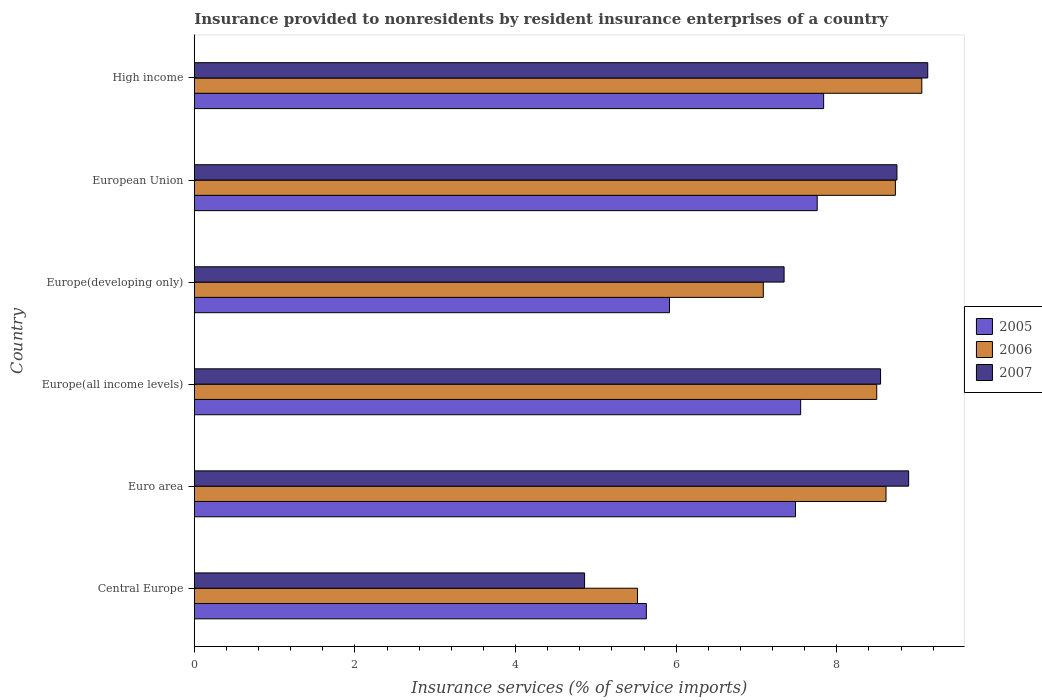Are the number of bars per tick equal to the number of legend labels?
Offer a very short reply. Yes. Are the number of bars on each tick of the Y-axis equal?
Keep it short and to the point. Yes. How many bars are there on the 4th tick from the top?
Offer a terse response. 3. How many bars are there on the 3rd tick from the bottom?
Offer a terse response. 3. What is the label of the 1st group of bars from the top?
Make the answer very short. High income. What is the insurance provided to nonresidents in 2005 in Europe(all income levels)?
Keep it short and to the point. 7.55. Across all countries, what is the maximum insurance provided to nonresidents in 2006?
Your answer should be very brief. 9.06. Across all countries, what is the minimum insurance provided to nonresidents in 2007?
Provide a short and direct response. 4.86. In which country was the insurance provided to nonresidents in 2005 minimum?
Your response must be concise. Central Europe. What is the total insurance provided to nonresidents in 2006 in the graph?
Your response must be concise. 47.5. What is the difference between the insurance provided to nonresidents in 2007 in Europe(all income levels) and that in European Union?
Give a very brief answer. -0.2. What is the difference between the insurance provided to nonresidents in 2007 in Euro area and the insurance provided to nonresidents in 2005 in Europe(all income levels)?
Ensure brevity in your answer.  1.34. What is the average insurance provided to nonresidents in 2007 per country?
Provide a succinct answer. 7.92. What is the difference between the insurance provided to nonresidents in 2006 and insurance provided to nonresidents in 2007 in High income?
Offer a terse response. -0.07. What is the ratio of the insurance provided to nonresidents in 2006 in European Union to that in High income?
Offer a terse response. 0.96. Is the insurance provided to nonresidents in 2005 in European Union less than that in High income?
Your answer should be very brief. Yes. What is the difference between the highest and the second highest insurance provided to nonresidents in 2005?
Offer a terse response. 0.08. What is the difference between the highest and the lowest insurance provided to nonresidents in 2006?
Keep it short and to the point. 3.54. What does the 2nd bar from the bottom in Europe(all income levels) represents?
Your answer should be compact. 2006. How many countries are there in the graph?
Your answer should be compact. 6. What is the difference between two consecutive major ticks on the X-axis?
Provide a succinct answer. 2. Are the values on the major ticks of X-axis written in scientific E-notation?
Offer a very short reply. No. Does the graph contain grids?
Keep it short and to the point. No. Where does the legend appear in the graph?
Offer a terse response. Center right. How are the legend labels stacked?
Give a very brief answer. Vertical. What is the title of the graph?
Keep it short and to the point. Insurance provided to nonresidents by resident insurance enterprises of a country. What is the label or title of the X-axis?
Give a very brief answer. Insurance services (% of service imports). What is the Insurance services (% of service imports) in 2005 in Central Europe?
Ensure brevity in your answer.  5.63. What is the Insurance services (% of service imports) of 2006 in Central Europe?
Make the answer very short. 5.52. What is the Insurance services (% of service imports) in 2007 in Central Europe?
Offer a very short reply. 4.86. What is the Insurance services (% of service imports) of 2005 in Euro area?
Provide a succinct answer. 7.49. What is the Insurance services (% of service imports) in 2006 in Euro area?
Give a very brief answer. 8.61. What is the Insurance services (% of service imports) in 2007 in Euro area?
Your answer should be compact. 8.9. What is the Insurance services (% of service imports) of 2005 in Europe(all income levels)?
Your response must be concise. 7.55. What is the Insurance services (% of service imports) in 2006 in Europe(all income levels)?
Provide a succinct answer. 8.5. What is the Insurance services (% of service imports) in 2007 in Europe(all income levels)?
Provide a succinct answer. 8.55. What is the Insurance services (% of service imports) of 2005 in Europe(developing only)?
Provide a succinct answer. 5.92. What is the Insurance services (% of service imports) in 2006 in Europe(developing only)?
Your answer should be compact. 7.09. What is the Insurance services (% of service imports) of 2007 in Europe(developing only)?
Keep it short and to the point. 7.34. What is the Insurance services (% of service imports) in 2005 in European Union?
Make the answer very short. 7.76. What is the Insurance services (% of service imports) in 2006 in European Union?
Your answer should be compact. 8.73. What is the Insurance services (% of service imports) of 2007 in European Union?
Make the answer very short. 8.75. What is the Insurance services (% of service imports) in 2005 in High income?
Ensure brevity in your answer.  7.84. What is the Insurance services (% of service imports) of 2006 in High income?
Keep it short and to the point. 9.06. What is the Insurance services (% of service imports) of 2007 in High income?
Provide a short and direct response. 9.13. Across all countries, what is the maximum Insurance services (% of service imports) in 2005?
Your response must be concise. 7.84. Across all countries, what is the maximum Insurance services (% of service imports) of 2006?
Provide a short and direct response. 9.06. Across all countries, what is the maximum Insurance services (% of service imports) in 2007?
Keep it short and to the point. 9.13. Across all countries, what is the minimum Insurance services (% of service imports) in 2005?
Your response must be concise. 5.63. Across all countries, what is the minimum Insurance services (% of service imports) in 2006?
Ensure brevity in your answer.  5.52. Across all countries, what is the minimum Insurance services (% of service imports) of 2007?
Make the answer very short. 4.86. What is the total Insurance services (% of service imports) in 2005 in the graph?
Ensure brevity in your answer.  42.18. What is the total Insurance services (% of service imports) in 2006 in the graph?
Provide a succinct answer. 47.5. What is the total Insurance services (% of service imports) in 2007 in the graph?
Make the answer very short. 47.53. What is the difference between the Insurance services (% of service imports) of 2005 in Central Europe and that in Euro area?
Provide a succinct answer. -1.86. What is the difference between the Insurance services (% of service imports) of 2006 in Central Europe and that in Euro area?
Your answer should be compact. -3.09. What is the difference between the Insurance services (% of service imports) in 2007 in Central Europe and that in Euro area?
Ensure brevity in your answer.  -4.04. What is the difference between the Insurance services (% of service imports) in 2005 in Central Europe and that in Europe(all income levels)?
Give a very brief answer. -1.92. What is the difference between the Insurance services (% of service imports) of 2006 in Central Europe and that in Europe(all income levels)?
Your answer should be compact. -2.98. What is the difference between the Insurance services (% of service imports) in 2007 in Central Europe and that in Europe(all income levels)?
Ensure brevity in your answer.  -3.69. What is the difference between the Insurance services (% of service imports) of 2005 in Central Europe and that in Europe(developing only)?
Offer a terse response. -0.29. What is the difference between the Insurance services (% of service imports) of 2006 in Central Europe and that in Europe(developing only)?
Make the answer very short. -1.57. What is the difference between the Insurance services (% of service imports) of 2007 in Central Europe and that in Europe(developing only)?
Ensure brevity in your answer.  -2.48. What is the difference between the Insurance services (% of service imports) in 2005 in Central Europe and that in European Union?
Offer a terse response. -2.13. What is the difference between the Insurance services (% of service imports) of 2006 in Central Europe and that in European Union?
Provide a succinct answer. -3.21. What is the difference between the Insurance services (% of service imports) in 2007 in Central Europe and that in European Union?
Make the answer very short. -3.89. What is the difference between the Insurance services (% of service imports) of 2005 in Central Europe and that in High income?
Provide a succinct answer. -2.21. What is the difference between the Insurance services (% of service imports) of 2006 in Central Europe and that in High income?
Your response must be concise. -3.54. What is the difference between the Insurance services (% of service imports) in 2007 in Central Europe and that in High income?
Provide a short and direct response. -4.27. What is the difference between the Insurance services (% of service imports) of 2005 in Euro area and that in Europe(all income levels)?
Make the answer very short. -0.06. What is the difference between the Insurance services (% of service imports) in 2006 in Euro area and that in Europe(all income levels)?
Your answer should be very brief. 0.12. What is the difference between the Insurance services (% of service imports) of 2007 in Euro area and that in Europe(all income levels)?
Ensure brevity in your answer.  0.35. What is the difference between the Insurance services (% of service imports) of 2005 in Euro area and that in Europe(developing only)?
Offer a terse response. 1.57. What is the difference between the Insurance services (% of service imports) of 2006 in Euro area and that in Europe(developing only)?
Your response must be concise. 1.53. What is the difference between the Insurance services (% of service imports) in 2007 in Euro area and that in Europe(developing only)?
Make the answer very short. 1.55. What is the difference between the Insurance services (% of service imports) in 2005 in Euro area and that in European Union?
Your response must be concise. -0.27. What is the difference between the Insurance services (% of service imports) in 2006 in Euro area and that in European Union?
Provide a short and direct response. -0.12. What is the difference between the Insurance services (% of service imports) of 2007 in Euro area and that in European Union?
Provide a succinct answer. 0.15. What is the difference between the Insurance services (% of service imports) of 2005 in Euro area and that in High income?
Your response must be concise. -0.35. What is the difference between the Insurance services (% of service imports) in 2006 in Euro area and that in High income?
Your response must be concise. -0.45. What is the difference between the Insurance services (% of service imports) of 2007 in Euro area and that in High income?
Your response must be concise. -0.24. What is the difference between the Insurance services (% of service imports) of 2005 in Europe(all income levels) and that in Europe(developing only)?
Your answer should be very brief. 1.63. What is the difference between the Insurance services (% of service imports) in 2006 in Europe(all income levels) and that in Europe(developing only)?
Your answer should be compact. 1.41. What is the difference between the Insurance services (% of service imports) in 2007 in Europe(all income levels) and that in Europe(developing only)?
Offer a terse response. 1.2. What is the difference between the Insurance services (% of service imports) of 2005 in Europe(all income levels) and that in European Union?
Your response must be concise. -0.21. What is the difference between the Insurance services (% of service imports) of 2006 in Europe(all income levels) and that in European Union?
Your answer should be very brief. -0.23. What is the difference between the Insurance services (% of service imports) in 2007 in Europe(all income levels) and that in European Union?
Offer a very short reply. -0.2. What is the difference between the Insurance services (% of service imports) of 2005 in Europe(all income levels) and that in High income?
Your answer should be compact. -0.29. What is the difference between the Insurance services (% of service imports) of 2006 in Europe(all income levels) and that in High income?
Offer a terse response. -0.56. What is the difference between the Insurance services (% of service imports) of 2007 in Europe(all income levels) and that in High income?
Your answer should be compact. -0.59. What is the difference between the Insurance services (% of service imports) in 2005 in Europe(developing only) and that in European Union?
Offer a very short reply. -1.84. What is the difference between the Insurance services (% of service imports) of 2006 in Europe(developing only) and that in European Union?
Offer a terse response. -1.64. What is the difference between the Insurance services (% of service imports) in 2007 in Europe(developing only) and that in European Union?
Your answer should be very brief. -1.41. What is the difference between the Insurance services (% of service imports) of 2005 in Europe(developing only) and that in High income?
Provide a succinct answer. -1.92. What is the difference between the Insurance services (% of service imports) of 2006 in Europe(developing only) and that in High income?
Your answer should be compact. -1.97. What is the difference between the Insurance services (% of service imports) of 2007 in Europe(developing only) and that in High income?
Your response must be concise. -1.79. What is the difference between the Insurance services (% of service imports) in 2005 in European Union and that in High income?
Keep it short and to the point. -0.08. What is the difference between the Insurance services (% of service imports) in 2006 in European Union and that in High income?
Your answer should be very brief. -0.33. What is the difference between the Insurance services (% of service imports) of 2007 in European Union and that in High income?
Provide a short and direct response. -0.38. What is the difference between the Insurance services (% of service imports) in 2005 in Central Europe and the Insurance services (% of service imports) in 2006 in Euro area?
Provide a short and direct response. -2.98. What is the difference between the Insurance services (% of service imports) of 2005 in Central Europe and the Insurance services (% of service imports) of 2007 in Euro area?
Provide a succinct answer. -3.27. What is the difference between the Insurance services (% of service imports) of 2006 in Central Europe and the Insurance services (% of service imports) of 2007 in Euro area?
Ensure brevity in your answer.  -3.38. What is the difference between the Insurance services (% of service imports) in 2005 in Central Europe and the Insurance services (% of service imports) in 2006 in Europe(all income levels)?
Provide a succinct answer. -2.87. What is the difference between the Insurance services (% of service imports) of 2005 in Central Europe and the Insurance services (% of service imports) of 2007 in Europe(all income levels)?
Provide a succinct answer. -2.92. What is the difference between the Insurance services (% of service imports) in 2006 in Central Europe and the Insurance services (% of service imports) in 2007 in Europe(all income levels)?
Offer a terse response. -3.03. What is the difference between the Insurance services (% of service imports) of 2005 in Central Europe and the Insurance services (% of service imports) of 2006 in Europe(developing only)?
Offer a terse response. -1.46. What is the difference between the Insurance services (% of service imports) in 2005 in Central Europe and the Insurance services (% of service imports) in 2007 in Europe(developing only)?
Give a very brief answer. -1.72. What is the difference between the Insurance services (% of service imports) in 2006 in Central Europe and the Insurance services (% of service imports) in 2007 in Europe(developing only)?
Provide a short and direct response. -1.83. What is the difference between the Insurance services (% of service imports) in 2005 in Central Europe and the Insurance services (% of service imports) in 2006 in European Union?
Your response must be concise. -3.1. What is the difference between the Insurance services (% of service imports) of 2005 in Central Europe and the Insurance services (% of service imports) of 2007 in European Union?
Ensure brevity in your answer.  -3.12. What is the difference between the Insurance services (% of service imports) in 2006 in Central Europe and the Insurance services (% of service imports) in 2007 in European Union?
Provide a succinct answer. -3.23. What is the difference between the Insurance services (% of service imports) in 2005 in Central Europe and the Insurance services (% of service imports) in 2006 in High income?
Your answer should be very brief. -3.43. What is the difference between the Insurance services (% of service imports) in 2005 in Central Europe and the Insurance services (% of service imports) in 2007 in High income?
Make the answer very short. -3.5. What is the difference between the Insurance services (% of service imports) in 2006 in Central Europe and the Insurance services (% of service imports) in 2007 in High income?
Your answer should be very brief. -3.61. What is the difference between the Insurance services (% of service imports) in 2005 in Euro area and the Insurance services (% of service imports) in 2006 in Europe(all income levels)?
Offer a very short reply. -1.01. What is the difference between the Insurance services (% of service imports) of 2005 in Euro area and the Insurance services (% of service imports) of 2007 in Europe(all income levels)?
Your answer should be very brief. -1.06. What is the difference between the Insurance services (% of service imports) in 2006 in Euro area and the Insurance services (% of service imports) in 2007 in Europe(all income levels)?
Your answer should be compact. 0.07. What is the difference between the Insurance services (% of service imports) in 2005 in Euro area and the Insurance services (% of service imports) in 2006 in Europe(developing only)?
Offer a terse response. 0.4. What is the difference between the Insurance services (% of service imports) in 2005 in Euro area and the Insurance services (% of service imports) in 2007 in Europe(developing only)?
Your answer should be compact. 0.14. What is the difference between the Insurance services (% of service imports) of 2006 in Euro area and the Insurance services (% of service imports) of 2007 in Europe(developing only)?
Make the answer very short. 1.27. What is the difference between the Insurance services (% of service imports) in 2005 in Euro area and the Insurance services (% of service imports) in 2006 in European Union?
Give a very brief answer. -1.24. What is the difference between the Insurance services (% of service imports) of 2005 in Euro area and the Insurance services (% of service imports) of 2007 in European Union?
Ensure brevity in your answer.  -1.26. What is the difference between the Insurance services (% of service imports) in 2006 in Euro area and the Insurance services (% of service imports) in 2007 in European Union?
Offer a very short reply. -0.14. What is the difference between the Insurance services (% of service imports) of 2005 in Euro area and the Insurance services (% of service imports) of 2006 in High income?
Make the answer very short. -1.57. What is the difference between the Insurance services (% of service imports) of 2005 in Euro area and the Insurance services (% of service imports) of 2007 in High income?
Keep it short and to the point. -1.65. What is the difference between the Insurance services (% of service imports) of 2006 in Euro area and the Insurance services (% of service imports) of 2007 in High income?
Your answer should be compact. -0.52. What is the difference between the Insurance services (% of service imports) of 2005 in Europe(all income levels) and the Insurance services (% of service imports) of 2006 in Europe(developing only)?
Give a very brief answer. 0.47. What is the difference between the Insurance services (% of service imports) of 2005 in Europe(all income levels) and the Insurance services (% of service imports) of 2007 in Europe(developing only)?
Give a very brief answer. 0.21. What is the difference between the Insurance services (% of service imports) in 2006 in Europe(all income levels) and the Insurance services (% of service imports) in 2007 in Europe(developing only)?
Provide a short and direct response. 1.15. What is the difference between the Insurance services (% of service imports) in 2005 in Europe(all income levels) and the Insurance services (% of service imports) in 2006 in European Union?
Your answer should be very brief. -1.18. What is the difference between the Insurance services (% of service imports) in 2005 in Europe(all income levels) and the Insurance services (% of service imports) in 2007 in European Union?
Your answer should be very brief. -1.2. What is the difference between the Insurance services (% of service imports) of 2006 in Europe(all income levels) and the Insurance services (% of service imports) of 2007 in European Union?
Offer a very short reply. -0.25. What is the difference between the Insurance services (% of service imports) of 2005 in Europe(all income levels) and the Insurance services (% of service imports) of 2006 in High income?
Your answer should be compact. -1.51. What is the difference between the Insurance services (% of service imports) in 2005 in Europe(all income levels) and the Insurance services (% of service imports) in 2007 in High income?
Keep it short and to the point. -1.58. What is the difference between the Insurance services (% of service imports) in 2006 in Europe(all income levels) and the Insurance services (% of service imports) in 2007 in High income?
Your answer should be compact. -0.64. What is the difference between the Insurance services (% of service imports) of 2005 in Europe(developing only) and the Insurance services (% of service imports) of 2006 in European Union?
Provide a short and direct response. -2.81. What is the difference between the Insurance services (% of service imports) of 2005 in Europe(developing only) and the Insurance services (% of service imports) of 2007 in European Union?
Give a very brief answer. -2.83. What is the difference between the Insurance services (% of service imports) of 2006 in Europe(developing only) and the Insurance services (% of service imports) of 2007 in European Union?
Make the answer very short. -1.66. What is the difference between the Insurance services (% of service imports) of 2005 in Europe(developing only) and the Insurance services (% of service imports) of 2006 in High income?
Make the answer very short. -3.14. What is the difference between the Insurance services (% of service imports) of 2005 in Europe(developing only) and the Insurance services (% of service imports) of 2007 in High income?
Provide a short and direct response. -3.22. What is the difference between the Insurance services (% of service imports) of 2006 in Europe(developing only) and the Insurance services (% of service imports) of 2007 in High income?
Your response must be concise. -2.05. What is the difference between the Insurance services (% of service imports) in 2005 in European Union and the Insurance services (% of service imports) in 2006 in High income?
Ensure brevity in your answer.  -1.3. What is the difference between the Insurance services (% of service imports) of 2005 in European Union and the Insurance services (% of service imports) of 2007 in High income?
Offer a terse response. -1.38. What is the difference between the Insurance services (% of service imports) in 2006 in European Union and the Insurance services (% of service imports) in 2007 in High income?
Your answer should be very brief. -0.4. What is the average Insurance services (% of service imports) in 2005 per country?
Your answer should be very brief. 7.03. What is the average Insurance services (% of service imports) in 2006 per country?
Keep it short and to the point. 7.92. What is the average Insurance services (% of service imports) of 2007 per country?
Your answer should be very brief. 7.92. What is the difference between the Insurance services (% of service imports) of 2005 and Insurance services (% of service imports) of 2006 in Central Europe?
Provide a short and direct response. 0.11. What is the difference between the Insurance services (% of service imports) of 2005 and Insurance services (% of service imports) of 2007 in Central Europe?
Provide a succinct answer. 0.77. What is the difference between the Insurance services (% of service imports) in 2006 and Insurance services (% of service imports) in 2007 in Central Europe?
Provide a short and direct response. 0.66. What is the difference between the Insurance services (% of service imports) in 2005 and Insurance services (% of service imports) in 2006 in Euro area?
Keep it short and to the point. -1.13. What is the difference between the Insurance services (% of service imports) in 2005 and Insurance services (% of service imports) in 2007 in Euro area?
Ensure brevity in your answer.  -1.41. What is the difference between the Insurance services (% of service imports) in 2006 and Insurance services (% of service imports) in 2007 in Euro area?
Your answer should be compact. -0.28. What is the difference between the Insurance services (% of service imports) in 2005 and Insurance services (% of service imports) in 2006 in Europe(all income levels)?
Ensure brevity in your answer.  -0.95. What is the difference between the Insurance services (% of service imports) in 2005 and Insurance services (% of service imports) in 2007 in Europe(all income levels)?
Make the answer very short. -1. What is the difference between the Insurance services (% of service imports) of 2006 and Insurance services (% of service imports) of 2007 in Europe(all income levels)?
Offer a very short reply. -0.05. What is the difference between the Insurance services (% of service imports) in 2005 and Insurance services (% of service imports) in 2006 in Europe(developing only)?
Give a very brief answer. -1.17. What is the difference between the Insurance services (% of service imports) in 2005 and Insurance services (% of service imports) in 2007 in Europe(developing only)?
Provide a short and direct response. -1.43. What is the difference between the Insurance services (% of service imports) in 2006 and Insurance services (% of service imports) in 2007 in Europe(developing only)?
Offer a very short reply. -0.26. What is the difference between the Insurance services (% of service imports) of 2005 and Insurance services (% of service imports) of 2006 in European Union?
Ensure brevity in your answer.  -0.97. What is the difference between the Insurance services (% of service imports) in 2005 and Insurance services (% of service imports) in 2007 in European Union?
Offer a terse response. -0.99. What is the difference between the Insurance services (% of service imports) of 2006 and Insurance services (% of service imports) of 2007 in European Union?
Your answer should be compact. -0.02. What is the difference between the Insurance services (% of service imports) of 2005 and Insurance services (% of service imports) of 2006 in High income?
Offer a very short reply. -1.22. What is the difference between the Insurance services (% of service imports) of 2005 and Insurance services (% of service imports) of 2007 in High income?
Offer a very short reply. -1.3. What is the difference between the Insurance services (% of service imports) in 2006 and Insurance services (% of service imports) in 2007 in High income?
Provide a succinct answer. -0.07. What is the ratio of the Insurance services (% of service imports) of 2005 in Central Europe to that in Euro area?
Your answer should be compact. 0.75. What is the ratio of the Insurance services (% of service imports) in 2006 in Central Europe to that in Euro area?
Your answer should be very brief. 0.64. What is the ratio of the Insurance services (% of service imports) of 2007 in Central Europe to that in Euro area?
Ensure brevity in your answer.  0.55. What is the ratio of the Insurance services (% of service imports) of 2005 in Central Europe to that in Europe(all income levels)?
Your response must be concise. 0.75. What is the ratio of the Insurance services (% of service imports) of 2006 in Central Europe to that in Europe(all income levels)?
Offer a terse response. 0.65. What is the ratio of the Insurance services (% of service imports) in 2007 in Central Europe to that in Europe(all income levels)?
Your answer should be very brief. 0.57. What is the ratio of the Insurance services (% of service imports) in 2005 in Central Europe to that in Europe(developing only)?
Ensure brevity in your answer.  0.95. What is the ratio of the Insurance services (% of service imports) of 2006 in Central Europe to that in Europe(developing only)?
Offer a terse response. 0.78. What is the ratio of the Insurance services (% of service imports) in 2007 in Central Europe to that in Europe(developing only)?
Offer a terse response. 0.66. What is the ratio of the Insurance services (% of service imports) in 2005 in Central Europe to that in European Union?
Ensure brevity in your answer.  0.73. What is the ratio of the Insurance services (% of service imports) in 2006 in Central Europe to that in European Union?
Your answer should be very brief. 0.63. What is the ratio of the Insurance services (% of service imports) of 2007 in Central Europe to that in European Union?
Your answer should be very brief. 0.56. What is the ratio of the Insurance services (% of service imports) of 2005 in Central Europe to that in High income?
Offer a terse response. 0.72. What is the ratio of the Insurance services (% of service imports) of 2006 in Central Europe to that in High income?
Your response must be concise. 0.61. What is the ratio of the Insurance services (% of service imports) in 2007 in Central Europe to that in High income?
Provide a succinct answer. 0.53. What is the ratio of the Insurance services (% of service imports) of 2006 in Euro area to that in Europe(all income levels)?
Make the answer very short. 1.01. What is the ratio of the Insurance services (% of service imports) of 2007 in Euro area to that in Europe(all income levels)?
Give a very brief answer. 1.04. What is the ratio of the Insurance services (% of service imports) of 2005 in Euro area to that in Europe(developing only)?
Provide a short and direct response. 1.27. What is the ratio of the Insurance services (% of service imports) of 2006 in Euro area to that in Europe(developing only)?
Make the answer very short. 1.22. What is the ratio of the Insurance services (% of service imports) of 2007 in Euro area to that in Europe(developing only)?
Offer a terse response. 1.21. What is the ratio of the Insurance services (% of service imports) of 2005 in Euro area to that in European Union?
Offer a very short reply. 0.97. What is the ratio of the Insurance services (% of service imports) of 2006 in Euro area to that in European Union?
Provide a short and direct response. 0.99. What is the ratio of the Insurance services (% of service imports) of 2007 in Euro area to that in European Union?
Provide a succinct answer. 1.02. What is the ratio of the Insurance services (% of service imports) of 2005 in Euro area to that in High income?
Offer a terse response. 0.96. What is the ratio of the Insurance services (% of service imports) in 2006 in Euro area to that in High income?
Ensure brevity in your answer.  0.95. What is the ratio of the Insurance services (% of service imports) of 2005 in Europe(all income levels) to that in Europe(developing only)?
Give a very brief answer. 1.28. What is the ratio of the Insurance services (% of service imports) of 2006 in Europe(all income levels) to that in Europe(developing only)?
Offer a terse response. 1.2. What is the ratio of the Insurance services (% of service imports) in 2007 in Europe(all income levels) to that in Europe(developing only)?
Your response must be concise. 1.16. What is the ratio of the Insurance services (% of service imports) of 2005 in Europe(all income levels) to that in European Union?
Provide a succinct answer. 0.97. What is the ratio of the Insurance services (% of service imports) in 2006 in Europe(all income levels) to that in European Union?
Ensure brevity in your answer.  0.97. What is the ratio of the Insurance services (% of service imports) of 2007 in Europe(all income levels) to that in European Union?
Give a very brief answer. 0.98. What is the ratio of the Insurance services (% of service imports) of 2005 in Europe(all income levels) to that in High income?
Ensure brevity in your answer.  0.96. What is the ratio of the Insurance services (% of service imports) in 2006 in Europe(all income levels) to that in High income?
Ensure brevity in your answer.  0.94. What is the ratio of the Insurance services (% of service imports) in 2007 in Europe(all income levels) to that in High income?
Provide a succinct answer. 0.94. What is the ratio of the Insurance services (% of service imports) in 2005 in Europe(developing only) to that in European Union?
Offer a terse response. 0.76. What is the ratio of the Insurance services (% of service imports) in 2006 in Europe(developing only) to that in European Union?
Offer a very short reply. 0.81. What is the ratio of the Insurance services (% of service imports) of 2007 in Europe(developing only) to that in European Union?
Your answer should be very brief. 0.84. What is the ratio of the Insurance services (% of service imports) in 2005 in Europe(developing only) to that in High income?
Make the answer very short. 0.76. What is the ratio of the Insurance services (% of service imports) of 2006 in Europe(developing only) to that in High income?
Offer a very short reply. 0.78. What is the ratio of the Insurance services (% of service imports) in 2007 in Europe(developing only) to that in High income?
Your response must be concise. 0.8. What is the ratio of the Insurance services (% of service imports) of 2005 in European Union to that in High income?
Your answer should be very brief. 0.99. What is the ratio of the Insurance services (% of service imports) in 2006 in European Union to that in High income?
Keep it short and to the point. 0.96. What is the ratio of the Insurance services (% of service imports) in 2007 in European Union to that in High income?
Offer a very short reply. 0.96. What is the difference between the highest and the second highest Insurance services (% of service imports) of 2005?
Offer a terse response. 0.08. What is the difference between the highest and the second highest Insurance services (% of service imports) in 2006?
Your answer should be compact. 0.33. What is the difference between the highest and the second highest Insurance services (% of service imports) in 2007?
Make the answer very short. 0.24. What is the difference between the highest and the lowest Insurance services (% of service imports) in 2005?
Keep it short and to the point. 2.21. What is the difference between the highest and the lowest Insurance services (% of service imports) in 2006?
Offer a terse response. 3.54. What is the difference between the highest and the lowest Insurance services (% of service imports) of 2007?
Ensure brevity in your answer.  4.27. 